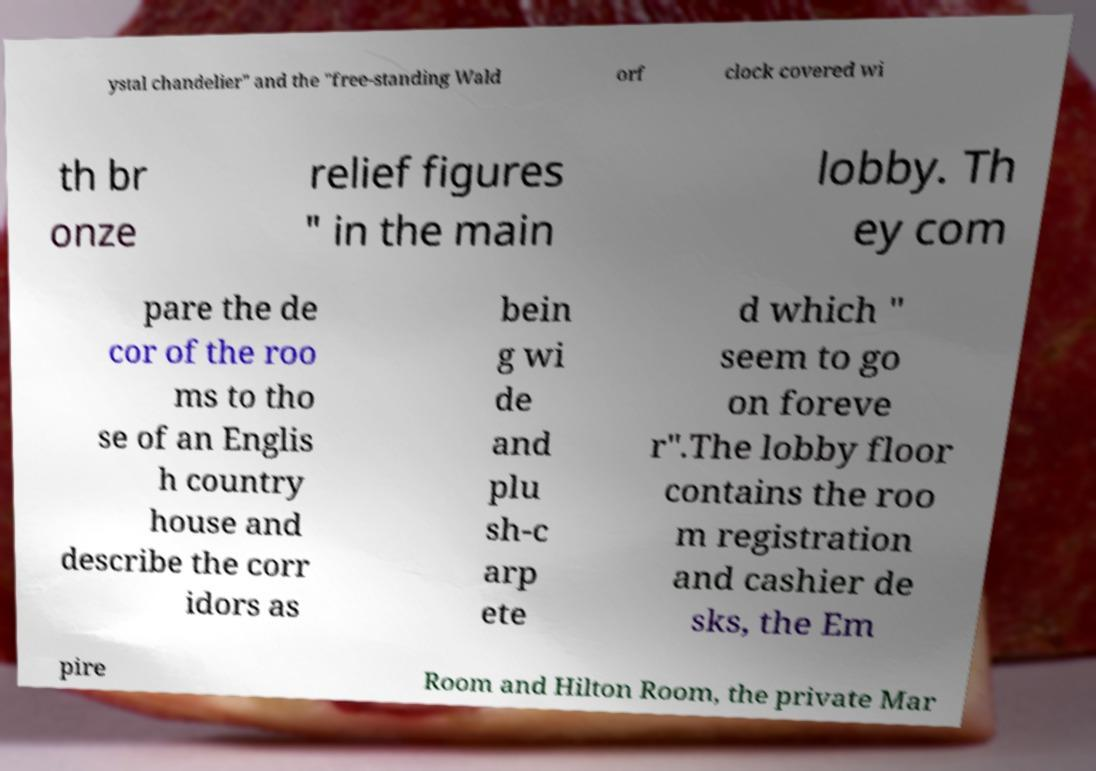Can you read and provide the text displayed in the image?This photo seems to have some interesting text. Can you extract and type it out for me? ystal chandelier" and the "free-standing Wald orf clock covered wi th br onze relief figures " in the main lobby. Th ey com pare the de cor of the roo ms to tho se of an Englis h country house and describe the corr idors as bein g wi de and plu sh-c arp ete d which " seem to go on foreve r".The lobby floor contains the roo m registration and cashier de sks, the Em pire Room and Hilton Room, the private Mar 